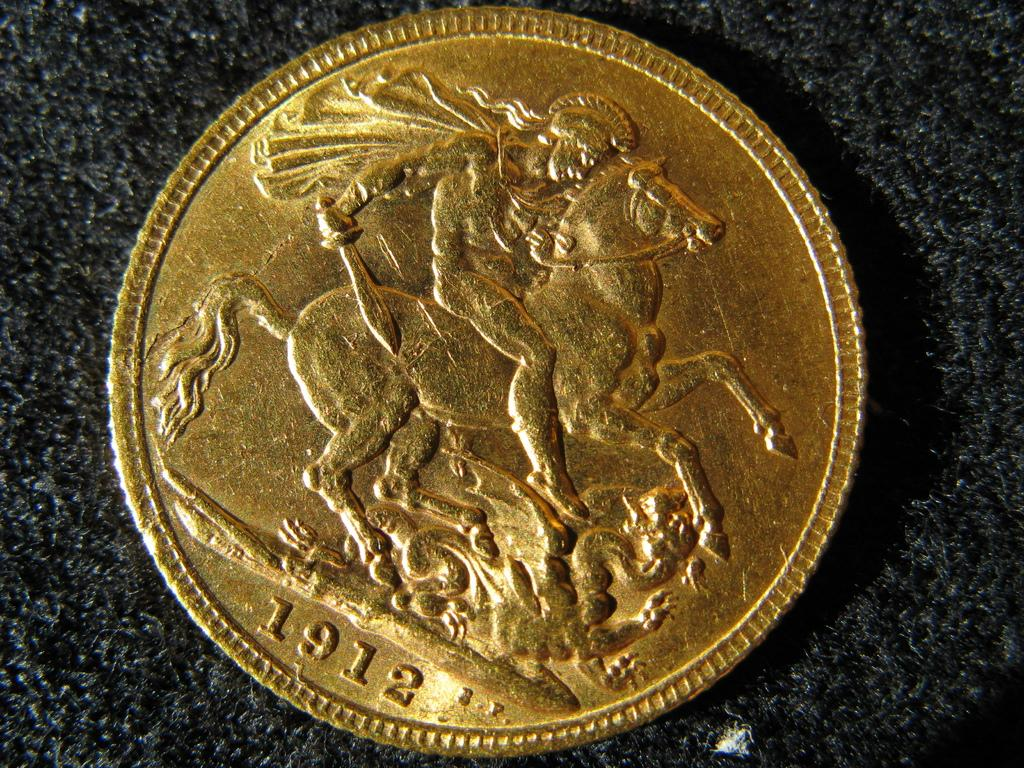<image>
Summarize the visual content of the image. A gold coin dated 1912 displays a person riding a horse. 